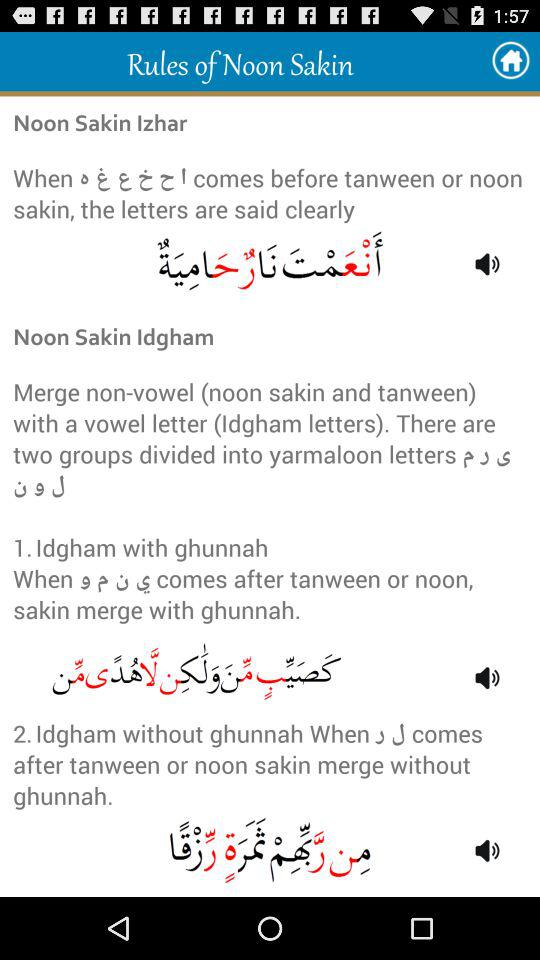How many rules of Noon Sakin are there?
Answer the question using a single word or phrase. 2 